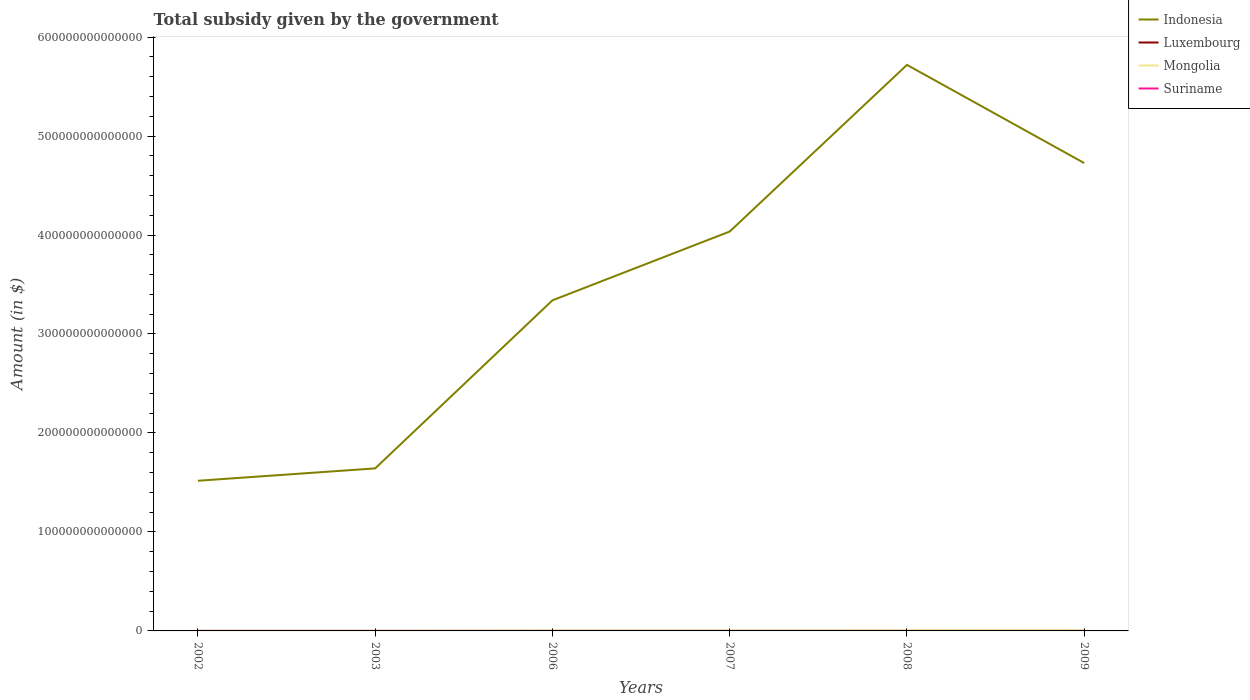How many different coloured lines are there?
Give a very brief answer. 4. Does the line corresponding to Indonesia intersect with the line corresponding to Suriname?
Provide a succinct answer. No. Is the number of lines equal to the number of legend labels?
Your response must be concise. Yes. Across all years, what is the maximum total revenue collected by the government in Indonesia?
Your answer should be very brief. 1.52e+14. What is the total total revenue collected by the government in Indonesia in the graph?
Your response must be concise. -3.21e+14. What is the difference between the highest and the second highest total revenue collected by the government in Luxembourg?
Your response must be concise. 4.64e+09. How many years are there in the graph?
Give a very brief answer. 6. What is the difference between two consecutive major ticks on the Y-axis?
Make the answer very short. 1.00e+14. Are the values on the major ticks of Y-axis written in scientific E-notation?
Provide a short and direct response. No. Where does the legend appear in the graph?
Offer a very short reply. Top right. How many legend labels are there?
Give a very brief answer. 4. How are the legend labels stacked?
Offer a terse response. Vertical. What is the title of the graph?
Provide a succinct answer. Total subsidy given by the government. What is the label or title of the Y-axis?
Provide a succinct answer. Amount (in $). What is the Amount (in $) in Indonesia in 2002?
Provide a short and direct response. 1.52e+14. What is the Amount (in $) in Luxembourg in 2002?
Give a very brief answer. 5.64e+09. What is the Amount (in $) in Mongolia in 2002?
Provide a succinct answer. 1.75e+11. What is the Amount (in $) of Suriname in 2002?
Make the answer very short. 1.62e+08. What is the Amount (in $) of Indonesia in 2003?
Offer a terse response. 1.64e+14. What is the Amount (in $) in Luxembourg in 2003?
Offer a very short reply. 6.17e+09. What is the Amount (in $) of Mongolia in 2003?
Give a very brief answer. 1.38e+11. What is the Amount (in $) in Suriname in 2003?
Your answer should be very brief. 1.98e+08. What is the Amount (in $) in Indonesia in 2006?
Provide a short and direct response. 3.34e+14. What is the Amount (in $) of Luxembourg in 2006?
Offer a very short reply. 8.23e+09. What is the Amount (in $) of Mongolia in 2006?
Make the answer very short. 4.41e+11. What is the Amount (in $) of Suriname in 2006?
Provide a short and direct response. 3.39e+08. What is the Amount (in $) of Indonesia in 2007?
Offer a very short reply. 4.04e+14. What is the Amount (in $) of Luxembourg in 2007?
Offer a very short reply. 8.66e+09. What is the Amount (in $) of Mongolia in 2007?
Your answer should be compact. 4.19e+11. What is the Amount (in $) in Suriname in 2007?
Provide a succinct answer. 3.92e+08. What is the Amount (in $) in Indonesia in 2008?
Your response must be concise. 5.72e+14. What is the Amount (in $) in Luxembourg in 2008?
Ensure brevity in your answer.  9.41e+09. What is the Amount (in $) in Mongolia in 2008?
Provide a short and direct response. 6.67e+11. What is the Amount (in $) in Suriname in 2008?
Ensure brevity in your answer.  4.36e+08. What is the Amount (in $) in Indonesia in 2009?
Make the answer very short. 4.73e+14. What is the Amount (in $) in Luxembourg in 2009?
Offer a terse response. 1.03e+1. What is the Amount (in $) in Mongolia in 2009?
Offer a very short reply. 7.77e+11. What is the Amount (in $) of Suriname in 2009?
Offer a very short reply. 5.00e+08. Across all years, what is the maximum Amount (in $) of Indonesia?
Offer a terse response. 5.72e+14. Across all years, what is the maximum Amount (in $) of Luxembourg?
Offer a terse response. 1.03e+1. Across all years, what is the maximum Amount (in $) of Mongolia?
Your answer should be very brief. 7.77e+11. Across all years, what is the maximum Amount (in $) of Suriname?
Provide a short and direct response. 5.00e+08. Across all years, what is the minimum Amount (in $) of Indonesia?
Your answer should be compact. 1.52e+14. Across all years, what is the minimum Amount (in $) of Luxembourg?
Offer a terse response. 5.64e+09. Across all years, what is the minimum Amount (in $) in Mongolia?
Offer a terse response. 1.38e+11. Across all years, what is the minimum Amount (in $) of Suriname?
Your answer should be very brief. 1.62e+08. What is the total Amount (in $) in Indonesia in the graph?
Provide a short and direct response. 2.10e+15. What is the total Amount (in $) of Luxembourg in the graph?
Offer a very short reply. 4.84e+1. What is the total Amount (in $) of Mongolia in the graph?
Keep it short and to the point. 2.62e+12. What is the total Amount (in $) of Suriname in the graph?
Your response must be concise. 2.03e+09. What is the difference between the Amount (in $) of Indonesia in 2002 and that in 2003?
Provide a succinct answer. -1.25e+13. What is the difference between the Amount (in $) in Luxembourg in 2002 and that in 2003?
Keep it short and to the point. -5.28e+08. What is the difference between the Amount (in $) of Mongolia in 2002 and that in 2003?
Your response must be concise. 3.69e+1. What is the difference between the Amount (in $) of Suriname in 2002 and that in 2003?
Ensure brevity in your answer.  -3.60e+07. What is the difference between the Amount (in $) of Indonesia in 2002 and that in 2006?
Your answer should be compact. -1.82e+14. What is the difference between the Amount (in $) of Luxembourg in 2002 and that in 2006?
Ensure brevity in your answer.  -2.59e+09. What is the difference between the Amount (in $) in Mongolia in 2002 and that in 2006?
Provide a succinct answer. -2.67e+11. What is the difference between the Amount (in $) in Suriname in 2002 and that in 2006?
Make the answer very short. -1.77e+08. What is the difference between the Amount (in $) of Indonesia in 2002 and that in 2007?
Ensure brevity in your answer.  -2.52e+14. What is the difference between the Amount (in $) of Luxembourg in 2002 and that in 2007?
Give a very brief answer. -3.02e+09. What is the difference between the Amount (in $) of Mongolia in 2002 and that in 2007?
Your answer should be very brief. -2.44e+11. What is the difference between the Amount (in $) in Suriname in 2002 and that in 2007?
Offer a terse response. -2.30e+08. What is the difference between the Amount (in $) of Indonesia in 2002 and that in 2008?
Give a very brief answer. -4.20e+14. What is the difference between the Amount (in $) of Luxembourg in 2002 and that in 2008?
Offer a very short reply. -3.77e+09. What is the difference between the Amount (in $) of Mongolia in 2002 and that in 2008?
Provide a short and direct response. -4.92e+11. What is the difference between the Amount (in $) of Suriname in 2002 and that in 2008?
Keep it short and to the point. -2.74e+08. What is the difference between the Amount (in $) in Indonesia in 2002 and that in 2009?
Provide a succinct answer. -3.21e+14. What is the difference between the Amount (in $) of Luxembourg in 2002 and that in 2009?
Offer a very short reply. -4.64e+09. What is the difference between the Amount (in $) of Mongolia in 2002 and that in 2009?
Provide a succinct answer. -6.02e+11. What is the difference between the Amount (in $) of Suriname in 2002 and that in 2009?
Offer a terse response. -3.38e+08. What is the difference between the Amount (in $) in Indonesia in 2003 and that in 2006?
Your answer should be compact. -1.70e+14. What is the difference between the Amount (in $) in Luxembourg in 2003 and that in 2006?
Your response must be concise. -2.06e+09. What is the difference between the Amount (in $) of Mongolia in 2003 and that in 2006?
Offer a terse response. -3.04e+11. What is the difference between the Amount (in $) of Suriname in 2003 and that in 2006?
Your response must be concise. -1.41e+08. What is the difference between the Amount (in $) in Indonesia in 2003 and that in 2007?
Provide a short and direct response. -2.39e+14. What is the difference between the Amount (in $) in Luxembourg in 2003 and that in 2007?
Provide a short and direct response. -2.49e+09. What is the difference between the Amount (in $) of Mongolia in 2003 and that in 2007?
Offer a terse response. -2.81e+11. What is the difference between the Amount (in $) of Suriname in 2003 and that in 2007?
Ensure brevity in your answer.  -1.94e+08. What is the difference between the Amount (in $) in Indonesia in 2003 and that in 2008?
Provide a short and direct response. -4.08e+14. What is the difference between the Amount (in $) in Luxembourg in 2003 and that in 2008?
Make the answer very short. -3.24e+09. What is the difference between the Amount (in $) of Mongolia in 2003 and that in 2008?
Your response must be concise. -5.29e+11. What is the difference between the Amount (in $) of Suriname in 2003 and that in 2008?
Provide a succinct answer. -2.38e+08. What is the difference between the Amount (in $) of Indonesia in 2003 and that in 2009?
Provide a succinct answer. -3.08e+14. What is the difference between the Amount (in $) of Luxembourg in 2003 and that in 2009?
Offer a very short reply. -4.11e+09. What is the difference between the Amount (in $) in Mongolia in 2003 and that in 2009?
Offer a very short reply. -6.39e+11. What is the difference between the Amount (in $) in Suriname in 2003 and that in 2009?
Ensure brevity in your answer.  -3.02e+08. What is the difference between the Amount (in $) of Indonesia in 2006 and that in 2007?
Offer a terse response. -6.95e+13. What is the difference between the Amount (in $) in Luxembourg in 2006 and that in 2007?
Your response must be concise. -4.32e+08. What is the difference between the Amount (in $) in Mongolia in 2006 and that in 2007?
Offer a very short reply. 2.24e+1. What is the difference between the Amount (in $) of Suriname in 2006 and that in 2007?
Provide a short and direct response. -5.32e+07. What is the difference between the Amount (in $) in Indonesia in 2006 and that in 2008?
Your answer should be compact. -2.38e+14. What is the difference between the Amount (in $) of Luxembourg in 2006 and that in 2008?
Keep it short and to the point. -1.18e+09. What is the difference between the Amount (in $) of Mongolia in 2006 and that in 2008?
Give a very brief answer. -2.26e+11. What is the difference between the Amount (in $) in Suriname in 2006 and that in 2008?
Your answer should be very brief. -9.70e+07. What is the difference between the Amount (in $) of Indonesia in 2006 and that in 2009?
Give a very brief answer. -1.39e+14. What is the difference between the Amount (in $) in Luxembourg in 2006 and that in 2009?
Make the answer very short. -2.05e+09. What is the difference between the Amount (in $) in Mongolia in 2006 and that in 2009?
Keep it short and to the point. -3.36e+11. What is the difference between the Amount (in $) in Suriname in 2006 and that in 2009?
Provide a succinct answer. -1.61e+08. What is the difference between the Amount (in $) of Indonesia in 2007 and that in 2008?
Your answer should be very brief. -1.68e+14. What is the difference between the Amount (in $) of Luxembourg in 2007 and that in 2008?
Your answer should be very brief. -7.48e+08. What is the difference between the Amount (in $) of Mongolia in 2007 and that in 2008?
Ensure brevity in your answer.  -2.48e+11. What is the difference between the Amount (in $) in Suriname in 2007 and that in 2008?
Your answer should be compact. -4.38e+07. What is the difference between the Amount (in $) in Indonesia in 2007 and that in 2009?
Make the answer very short. -6.92e+13. What is the difference between the Amount (in $) of Luxembourg in 2007 and that in 2009?
Offer a very short reply. -1.62e+09. What is the difference between the Amount (in $) in Mongolia in 2007 and that in 2009?
Give a very brief answer. -3.58e+11. What is the difference between the Amount (in $) of Suriname in 2007 and that in 2009?
Provide a succinct answer. -1.08e+08. What is the difference between the Amount (in $) of Indonesia in 2008 and that in 2009?
Offer a terse response. 9.92e+13. What is the difference between the Amount (in $) in Luxembourg in 2008 and that in 2009?
Provide a succinct answer. -8.68e+08. What is the difference between the Amount (in $) in Mongolia in 2008 and that in 2009?
Your answer should be very brief. -1.10e+11. What is the difference between the Amount (in $) of Suriname in 2008 and that in 2009?
Your answer should be compact. -6.43e+07. What is the difference between the Amount (in $) in Indonesia in 2002 and the Amount (in $) in Luxembourg in 2003?
Offer a very short reply. 1.52e+14. What is the difference between the Amount (in $) in Indonesia in 2002 and the Amount (in $) in Mongolia in 2003?
Give a very brief answer. 1.52e+14. What is the difference between the Amount (in $) in Indonesia in 2002 and the Amount (in $) in Suriname in 2003?
Provide a short and direct response. 1.52e+14. What is the difference between the Amount (in $) in Luxembourg in 2002 and the Amount (in $) in Mongolia in 2003?
Provide a succinct answer. -1.32e+11. What is the difference between the Amount (in $) of Luxembourg in 2002 and the Amount (in $) of Suriname in 2003?
Provide a short and direct response. 5.45e+09. What is the difference between the Amount (in $) of Mongolia in 2002 and the Amount (in $) of Suriname in 2003?
Your response must be concise. 1.75e+11. What is the difference between the Amount (in $) of Indonesia in 2002 and the Amount (in $) of Luxembourg in 2006?
Offer a terse response. 1.52e+14. What is the difference between the Amount (in $) of Indonesia in 2002 and the Amount (in $) of Mongolia in 2006?
Make the answer very short. 1.51e+14. What is the difference between the Amount (in $) in Indonesia in 2002 and the Amount (in $) in Suriname in 2006?
Offer a terse response. 1.52e+14. What is the difference between the Amount (in $) in Luxembourg in 2002 and the Amount (in $) in Mongolia in 2006?
Make the answer very short. -4.36e+11. What is the difference between the Amount (in $) in Luxembourg in 2002 and the Amount (in $) in Suriname in 2006?
Your answer should be compact. 5.30e+09. What is the difference between the Amount (in $) in Mongolia in 2002 and the Amount (in $) in Suriname in 2006?
Make the answer very short. 1.74e+11. What is the difference between the Amount (in $) of Indonesia in 2002 and the Amount (in $) of Luxembourg in 2007?
Offer a terse response. 1.52e+14. What is the difference between the Amount (in $) in Indonesia in 2002 and the Amount (in $) in Mongolia in 2007?
Your answer should be compact. 1.51e+14. What is the difference between the Amount (in $) of Indonesia in 2002 and the Amount (in $) of Suriname in 2007?
Provide a short and direct response. 1.52e+14. What is the difference between the Amount (in $) of Luxembourg in 2002 and the Amount (in $) of Mongolia in 2007?
Make the answer very short. -4.13e+11. What is the difference between the Amount (in $) in Luxembourg in 2002 and the Amount (in $) in Suriname in 2007?
Make the answer very short. 5.25e+09. What is the difference between the Amount (in $) in Mongolia in 2002 and the Amount (in $) in Suriname in 2007?
Offer a terse response. 1.74e+11. What is the difference between the Amount (in $) of Indonesia in 2002 and the Amount (in $) of Luxembourg in 2008?
Offer a terse response. 1.52e+14. What is the difference between the Amount (in $) in Indonesia in 2002 and the Amount (in $) in Mongolia in 2008?
Your answer should be compact. 1.51e+14. What is the difference between the Amount (in $) in Indonesia in 2002 and the Amount (in $) in Suriname in 2008?
Keep it short and to the point. 1.52e+14. What is the difference between the Amount (in $) in Luxembourg in 2002 and the Amount (in $) in Mongolia in 2008?
Provide a succinct answer. -6.61e+11. What is the difference between the Amount (in $) of Luxembourg in 2002 and the Amount (in $) of Suriname in 2008?
Provide a succinct answer. 5.21e+09. What is the difference between the Amount (in $) in Mongolia in 2002 and the Amount (in $) in Suriname in 2008?
Keep it short and to the point. 1.74e+11. What is the difference between the Amount (in $) of Indonesia in 2002 and the Amount (in $) of Luxembourg in 2009?
Your answer should be compact. 1.52e+14. What is the difference between the Amount (in $) of Indonesia in 2002 and the Amount (in $) of Mongolia in 2009?
Your response must be concise. 1.51e+14. What is the difference between the Amount (in $) in Indonesia in 2002 and the Amount (in $) in Suriname in 2009?
Make the answer very short. 1.52e+14. What is the difference between the Amount (in $) of Luxembourg in 2002 and the Amount (in $) of Mongolia in 2009?
Your answer should be very brief. -7.71e+11. What is the difference between the Amount (in $) of Luxembourg in 2002 and the Amount (in $) of Suriname in 2009?
Ensure brevity in your answer.  5.14e+09. What is the difference between the Amount (in $) of Mongolia in 2002 and the Amount (in $) of Suriname in 2009?
Your response must be concise. 1.74e+11. What is the difference between the Amount (in $) of Indonesia in 2003 and the Amount (in $) of Luxembourg in 2006?
Make the answer very short. 1.64e+14. What is the difference between the Amount (in $) of Indonesia in 2003 and the Amount (in $) of Mongolia in 2006?
Your response must be concise. 1.64e+14. What is the difference between the Amount (in $) in Indonesia in 2003 and the Amount (in $) in Suriname in 2006?
Your answer should be very brief. 1.64e+14. What is the difference between the Amount (in $) of Luxembourg in 2003 and the Amount (in $) of Mongolia in 2006?
Your answer should be compact. -4.35e+11. What is the difference between the Amount (in $) in Luxembourg in 2003 and the Amount (in $) in Suriname in 2006?
Your response must be concise. 5.83e+09. What is the difference between the Amount (in $) of Mongolia in 2003 and the Amount (in $) of Suriname in 2006?
Your answer should be very brief. 1.37e+11. What is the difference between the Amount (in $) in Indonesia in 2003 and the Amount (in $) in Luxembourg in 2007?
Provide a short and direct response. 1.64e+14. What is the difference between the Amount (in $) in Indonesia in 2003 and the Amount (in $) in Mongolia in 2007?
Give a very brief answer. 1.64e+14. What is the difference between the Amount (in $) of Indonesia in 2003 and the Amount (in $) of Suriname in 2007?
Give a very brief answer. 1.64e+14. What is the difference between the Amount (in $) of Luxembourg in 2003 and the Amount (in $) of Mongolia in 2007?
Offer a terse response. -4.13e+11. What is the difference between the Amount (in $) in Luxembourg in 2003 and the Amount (in $) in Suriname in 2007?
Your response must be concise. 5.78e+09. What is the difference between the Amount (in $) of Mongolia in 2003 and the Amount (in $) of Suriname in 2007?
Give a very brief answer. 1.37e+11. What is the difference between the Amount (in $) of Indonesia in 2003 and the Amount (in $) of Luxembourg in 2008?
Ensure brevity in your answer.  1.64e+14. What is the difference between the Amount (in $) of Indonesia in 2003 and the Amount (in $) of Mongolia in 2008?
Make the answer very short. 1.64e+14. What is the difference between the Amount (in $) of Indonesia in 2003 and the Amount (in $) of Suriname in 2008?
Your response must be concise. 1.64e+14. What is the difference between the Amount (in $) in Luxembourg in 2003 and the Amount (in $) in Mongolia in 2008?
Your response must be concise. -6.61e+11. What is the difference between the Amount (in $) in Luxembourg in 2003 and the Amount (in $) in Suriname in 2008?
Make the answer very short. 5.74e+09. What is the difference between the Amount (in $) of Mongolia in 2003 and the Amount (in $) of Suriname in 2008?
Provide a succinct answer. 1.37e+11. What is the difference between the Amount (in $) of Indonesia in 2003 and the Amount (in $) of Luxembourg in 2009?
Your answer should be compact. 1.64e+14. What is the difference between the Amount (in $) in Indonesia in 2003 and the Amount (in $) in Mongolia in 2009?
Provide a succinct answer. 1.63e+14. What is the difference between the Amount (in $) in Indonesia in 2003 and the Amount (in $) in Suriname in 2009?
Your answer should be compact. 1.64e+14. What is the difference between the Amount (in $) in Luxembourg in 2003 and the Amount (in $) in Mongolia in 2009?
Keep it short and to the point. -7.71e+11. What is the difference between the Amount (in $) in Luxembourg in 2003 and the Amount (in $) in Suriname in 2009?
Make the answer very short. 5.67e+09. What is the difference between the Amount (in $) of Mongolia in 2003 and the Amount (in $) of Suriname in 2009?
Your answer should be compact. 1.37e+11. What is the difference between the Amount (in $) in Indonesia in 2006 and the Amount (in $) in Luxembourg in 2007?
Provide a succinct answer. 3.34e+14. What is the difference between the Amount (in $) of Indonesia in 2006 and the Amount (in $) of Mongolia in 2007?
Provide a succinct answer. 3.34e+14. What is the difference between the Amount (in $) of Indonesia in 2006 and the Amount (in $) of Suriname in 2007?
Your answer should be compact. 3.34e+14. What is the difference between the Amount (in $) in Luxembourg in 2006 and the Amount (in $) in Mongolia in 2007?
Provide a short and direct response. -4.11e+11. What is the difference between the Amount (in $) in Luxembourg in 2006 and the Amount (in $) in Suriname in 2007?
Make the answer very short. 7.84e+09. What is the difference between the Amount (in $) of Mongolia in 2006 and the Amount (in $) of Suriname in 2007?
Provide a short and direct response. 4.41e+11. What is the difference between the Amount (in $) of Indonesia in 2006 and the Amount (in $) of Luxembourg in 2008?
Keep it short and to the point. 3.34e+14. What is the difference between the Amount (in $) of Indonesia in 2006 and the Amount (in $) of Mongolia in 2008?
Provide a short and direct response. 3.33e+14. What is the difference between the Amount (in $) in Indonesia in 2006 and the Amount (in $) in Suriname in 2008?
Give a very brief answer. 3.34e+14. What is the difference between the Amount (in $) in Luxembourg in 2006 and the Amount (in $) in Mongolia in 2008?
Give a very brief answer. -6.59e+11. What is the difference between the Amount (in $) of Luxembourg in 2006 and the Amount (in $) of Suriname in 2008?
Provide a succinct answer. 7.80e+09. What is the difference between the Amount (in $) of Mongolia in 2006 and the Amount (in $) of Suriname in 2008?
Provide a short and direct response. 4.41e+11. What is the difference between the Amount (in $) in Indonesia in 2006 and the Amount (in $) in Luxembourg in 2009?
Keep it short and to the point. 3.34e+14. What is the difference between the Amount (in $) of Indonesia in 2006 and the Amount (in $) of Mongolia in 2009?
Provide a succinct answer. 3.33e+14. What is the difference between the Amount (in $) of Indonesia in 2006 and the Amount (in $) of Suriname in 2009?
Ensure brevity in your answer.  3.34e+14. What is the difference between the Amount (in $) of Luxembourg in 2006 and the Amount (in $) of Mongolia in 2009?
Keep it short and to the point. -7.69e+11. What is the difference between the Amount (in $) of Luxembourg in 2006 and the Amount (in $) of Suriname in 2009?
Your answer should be compact. 7.73e+09. What is the difference between the Amount (in $) of Mongolia in 2006 and the Amount (in $) of Suriname in 2009?
Provide a succinct answer. 4.41e+11. What is the difference between the Amount (in $) of Indonesia in 2007 and the Amount (in $) of Luxembourg in 2008?
Provide a succinct answer. 4.04e+14. What is the difference between the Amount (in $) in Indonesia in 2007 and the Amount (in $) in Mongolia in 2008?
Ensure brevity in your answer.  4.03e+14. What is the difference between the Amount (in $) of Indonesia in 2007 and the Amount (in $) of Suriname in 2008?
Keep it short and to the point. 4.04e+14. What is the difference between the Amount (in $) of Luxembourg in 2007 and the Amount (in $) of Mongolia in 2008?
Provide a succinct answer. -6.58e+11. What is the difference between the Amount (in $) of Luxembourg in 2007 and the Amount (in $) of Suriname in 2008?
Your response must be concise. 8.23e+09. What is the difference between the Amount (in $) of Mongolia in 2007 and the Amount (in $) of Suriname in 2008?
Provide a succinct answer. 4.18e+11. What is the difference between the Amount (in $) of Indonesia in 2007 and the Amount (in $) of Luxembourg in 2009?
Ensure brevity in your answer.  4.04e+14. What is the difference between the Amount (in $) of Indonesia in 2007 and the Amount (in $) of Mongolia in 2009?
Make the answer very short. 4.03e+14. What is the difference between the Amount (in $) in Indonesia in 2007 and the Amount (in $) in Suriname in 2009?
Offer a very short reply. 4.04e+14. What is the difference between the Amount (in $) in Luxembourg in 2007 and the Amount (in $) in Mongolia in 2009?
Provide a short and direct response. -7.68e+11. What is the difference between the Amount (in $) of Luxembourg in 2007 and the Amount (in $) of Suriname in 2009?
Ensure brevity in your answer.  8.16e+09. What is the difference between the Amount (in $) of Mongolia in 2007 and the Amount (in $) of Suriname in 2009?
Keep it short and to the point. 4.18e+11. What is the difference between the Amount (in $) in Indonesia in 2008 and the Amount (in $) in Luxembourg in 2009?
Give a very brief answer. 5.72e+14. What is the difference between the Amount (in $) in Indonesia in 2008 and the Amount (in $) in Mongolia in 2009?
Offer a terse response. 5.71e+14. What is the difference between the Amount (in $) of Indonesia in 2008 and the Amount (in $) of Suriname in 2009?
Your answer should be very brief. 5.72e+14. What is the difference between the Amount (in $) in Luxembourg in 2008 and the Amount (in $) in Mongolia in 2009?
Your answer should be very brief. -7.68e+11. What is the difference between the Amount (in $) of Luxembourg in 2008 and the Amount (in $) of Suriname in 2009?
Make the answer very short. 8.91e+09. What is the difference between the Amount (in $) in Mongolia in 2008 and the Amount (in $) in Suriname in 2009?
Provide a succinct answer. 6.66e+11. What is the average Amount (in $) in Indonesia per year?
Provide a succinct answer. 3.50e+14. What is the average Amount (in $) in Luxembourg per year?
Your response must be concise. 8.07e+09. What is the average Amount (in $) in Mongolia per year?
Your answer should be very brief. 4.36e+11. What is the average Amount (in $) in Suriname per year?
Give a very brief answer. 3.38e+08. In the year 2002, what is the difference between the Amount (in $) in Indonesia and Amount (in $) in Luxembourg?
Provide a succinct answer. 1.52e+14. In the year 2002, what is the difference between the Amount (in $) in Indonesia and Amount (in $) in Mongolia?
Your answer should be compact. 1.52e+14. In the year 2002, what is the difference between the Amount (in $) of Indonesia and Amount (in $) of Suriname?
Your response must be concise. 1.52e+14. In the year 2002, what is the difference between the Amount (in $) of Luxembourg and Amount (in $) of Mongolia?
Your answer should be very brief. -1.69e+11. In the year 2002, what is the difference between the Amount (in $) in Luxembourg and Amount (in $) in Suriname?
Provide a short and direct response. 5.48e+09. In the year 2002, what is the difference between the Amount (in $) of Mongolia and Amount (in $) of Suriname?
Make the answer very short. 1.75e+11. In the year 2003, what is the difference between the Amount (in $) of Indonesia and Amount (in $) of Luxembourg?
Your answer should be compact. 1.64e+14. In the year 2003, what is the difference between the Amount (in $) in Indonesia and Amount (in $) in Mongolia?
Keep it short and to the point. 1.64e+14. In the year 2003, what is the difference between the Amount (in $) of Indonesia and Amount (in $) of Suriname?
Make the answer very short. 1.64e+14. In the year 2003, what is the difference between the Amount (in $) in Luxembourg and Amount (in $) in Mongolia?
Provide a short and direct response. -1.32e+11. In the year 2003, what is the difference between the Amount (in $) in Luxembourg and Amount (in $) in Suriname?
Your answer should be very brief. 5.97e+09. In the year 2003, what is the difference between the Amount (in $) in Mongolia and Amount (in $) in Suriname?
Offer a very short reply. 1.38e+11. In the year 2006, what is the difference between the Amount (in $) of Indonesia and Amount (in $) of Luxembourg?
Offer a terse response. 3.34e+14. In the year 2006, what is the difference between the Amount (in $) in Indonesia and Amount (in $) in Mongolia?
Offer a very short reply. 3.34e+14. In the year 2006, what is the difference between the Amount (in $) in Indonesia and Amount (in $) in Suriname?
Offer a very short reply. 3.34e+14. In the year 2006, what is the difference between the Amount (in $) of Luxembourg and Amount (in $) of Mongolia?
Keep it short and to the point. -4.33e+11. In the year 2006, what is the difference between the Amount (in $) of Luxembourg and Amount (in $) of Suriname?
Make the answer very short. 7.89e+09. In the year 2006, what is the difference between the Amount (in $) of Mongolia and Amount (in $) of Suriname?
Your answer should be very brief. 4.41e+11. In the year 2007, what is the difference between the Amount (in $) in Indonesia and Amount (in $) in Luxembourg?
Your response must be concise. 4.04e+14. In the year 2007, what is the difference between the Amount (in $) in Indonesia and Amount (in $) in Mongolia?
Provide a short and direct response. 4.03e+14. In the year 2007, what is the difference between the Amount (in $) in Indonesia and Amount (in $) in Suriname?
Your answer should be compact. 4.04e+14. In the year 2007, what is the difference between the Amount (in $) in Luxembourg and Amount (in $) in Mongolia?
Your answer should be very brief. -4.10e+11. In the year 2007, what is the difference between the Amount (in $) in Luxembourg and Amount (in $) in Suriname?
Your answer should be very brief. 8.27e+09. In the year 2007, what is the difference between the Amount (in $) in Mongolia and Amount (in $) in Suriname?
Your answer should be very brief. 4.19e+11. In the year 2008, what is the difference between the Amount (in $) in Indonesia and Amount (in $) in Luxembourg?
Make the answer very short. 5.72e+14. In the year 2008, what is the difference between the Amount (in $) of Indonesia and Amount (in $) of Mongolia?
Offer a very short reply. 5.71e+14. In the year 2008, what is the difference between the Amount (in $) of Indonesia and Amount (in $) of Suriname?
Your answer should be compact. 5.72e+14. In the year 2008, what is the difference between the Amount (in $) in Luxembourg and Amount (in $) in Mongolia?
Offer a terse response. -6.57e+11. In the year 2008, what is the difference between the Amount (in $) of Luxembourg and Amount (in $) of Suriname?
Keep it short and to the point. 8.98e+09. In the year 2008, what is the difference between the Amount (in $) in Mongolia and Amount (in $) in Suriname?
Provide a succinct answer. 6.66e+11. In the year 2009, what is the difference between the Amount (in $) of Indonesia and Amount (in $) of Luxembourg?
Provide a short and direct response. 4.73e+14. In the year 2009, what is the difference between the Amount (in $) of Indonesia and Amount (in $) of Mongolia?
Make the answer very short. 4.72e+14. In the year 2009, what is the difference between the Amount (in $) of Indonesia and Amount (in $) of Suriname?
Ensure brevity in your answer.  4.73e+14. In the year 2009, what is the difference between the Amount (in $) of Luxembourg and Amount (in $) of Mongolia?
Offer a very short reply. -7.67e+11. In the year 2009, what is the difference between the Amount (in $) in Luxembourg and Amount (in $) in Suriname?
Your answer should be very brief. 9.78e+09. In the year 2009, what is the difference between the Amount (in $) in Mongolia and Amount (in $) in Suriname?
Provide a succinct answer. 7.76e+11. What is the ratio of the Amount (in $) in Indonesia in 2002 to that in 2003?
Offer a terse response. 0.92. What is the ratio of the Amount (in $) of Luxembourg in 2002 to that in 2003?
Your answer should be very brief. 0.91. What is the ratio of the Amount (in $) in Mongolia in 2002 to that in 2003?
Your response must be concise. 1.27. What is the ratio of the Amount (in $) in Suriname in 2002 to that in 2003?
Make the answer very short. 0.82. What is the ratio of the Amount (in $) of Indonesia in 2002 to that in 2006?
Give a very brief answer. 0.45. What is the ratio of the Amount (in $) of Luxembourg in 2002 to that in 2006?
Keep it short and to the point. 0.69. What is the ratio of the Amount (in $) in Mongolia in 2002 to that in 2006?
Give a very brief answer. 0.4. What is the ratio of the Amount (in $) in Suriname in 2002 to that in 2006?
Keep it short and to the point. 0.48. What is the ratio of the Amount (in $) in Indonesia in 2002 to that in 2007?
Offer a terse response. 0.38. What is the ratio of the Amount (in $) of Luxembourg in 2002 to that in 2007?
Provide a short and direct response. 0.65. What is the ratio of the Amount (in $) in Mongolia in 2002 to that in 2007?
Offer a terse response. 0.42. What is the ratio of the Amount (in $) in Suriname in 2002 to that in 2007?
Give a very brief answer. 0.41. What is the ratio of the Amount (in $) in Indonesia in 2002 to that in 2008?
Provide a short and direct response. 0.27. What is the ratio of the Amount (in $) in Luxembourg in 2002 to that in 2008?
Offer a very short reply. 0.6. What is the ratio of the Amount (in $) of Mongolia in 2002 to that in 2008?
Offer a terse response. 0.26. What is the ratio of the Amount (in $) of Suriname in 2002 to that in 2008?
Offer a very short reply. 0.37. What is the ratio of the Amount (in $) of Indonesia in 2002 to that in 2009?
Ensure brevity in your answer.  0.32. What is the ratio of the Amount (in $) of Luxembourg in 2002 to that in 2009?
Your response must be concise. 0.55. What is the ratio of the Amount (in $) of Mongolia in 2002 to that in 2009?
Provide a short and direct response. 0.22. What is the ratio of the Amount (in $) of Suriname in 2002 to that in 2009?
Offer a very short reply. 0.32. What is the ratio of the Amount (in $) of Indonesia in 2003 to that in 2006?
Provide a succinct answer. 0.49. What is the ratio of the Amount (in $) of Luxembourg in 2003 to that in 2006?
Offer a terse response. 0.75. What is the ratio of the Amount (in $) of Mongolia in 2003 to that in 2006?
Ensure brevity in your answer.  0.31. What is the ratio of the Amount (in $) in Suriname in 2003 to that in 2006?
Your answer should be compact. 0.58. What is the ratio of the Amount (in $) of Indonesia in 2003 to that in 2007?
Offer a very short reply. 0.41. What is the ratio of the Amount (in $) of Luxembourg in 2003 to that in 2007?
Provide a succinct answer. 0.71. What is the ratio of the Amount (in $) in Mongolia in 2003 to that in 2007?
Your answer should be compact. 0.33. What is the ratio of the Amount (in $) in Suriname in 2003 to that in 2007?
Offer a terse response. 0.51. What is the ratio of the Amount (in $) of Indonesia in 2003 to that in 2008?
Your answer should be very brief. 0.29. What is the ratio of the Amount (in $) of Luxembourg in 2003 to that in 2008?
Your answer should be compact. 0.66. What is the ratio of the Amount (in $) of Mongolia in 2003 to that in 2008?
Provide a short and direct response. 0.21. What is the ratio of the Amount (in $) in Suriname in 2003 to that in 2008?
Keep it short and to the point. 0.45. What is the ratio of the Amount (in $) in Indonesia in 2003 to that in 2009?
Provide a succinct answer. 0.35. What is the ratio of the Amount (in $) in Luxembourg in 2003 to that in 2009?
Keep it short and to the point. 0.6. What is the ratio of the Amount (in $) of Mongolia in 2003 to that in 2009?
Your response must be concise. 0.18. What is the ratio of the Amount (in $) in Suriname in 2003 to that in 2009?
Offer a terse response. 0.4. What is the ratio of the Amount (in $) in Indonesia in 2006 to that in 2007?
Offer a very short reply. 0.83. What is the ratio of the Amount (in $) in Luxembourg in 2006 to that in 2007?
Make the answer very short. 0.95. What is the ratio of the Amount (in $) of Mongolia in 2006 to that in 2007?
Provide a succinct answer. 1.05. What is the ratio of the Amount (in $) in Suriname in 2006 to that in 2007?
Provide a succinct answer. 0.86. What is the ratio of the Amount (in $) of Indonesia in 2006 to that in 2008?
Your response must be concise. 0.58. What is the ratio of the Amount (in $) in Luxembourg in 2006 to that in 2008?
Offer a terse response. 0.87. What is the ratio of the Amount (in $) of Mongolia in 2006 to that in 2008?
Ensure brevity in your answer.  0.66. What is the ratio of the Amount (in $) in Suriname in 2006 to that in 2008?
Your response must be concise. 0.78. What is the ratio of the Amount (in $) of Indonesia in 2006 to that in 2009?
Provide a short and direct response. 0.71. What is the ratio of the Amount (in $) of Luxembourg in 2006 to that in 2009?
Provide a short and direct response. 0.8. What is the ratio of the Amount (in $) of Mongolia in 2006 to that in 2009?
Provide a short and direct response. 0.57. What is the ratio of the Amount (in $) of Suriname in 2006 to that in 2009?
Give a very brief answer. 0.68. What is the ratio of the Amount (in $) in Indonesia in 2007 to that in 2008?
Your response must be concise. 0.71. What is the ratio of the Amount (in $) in Luxembourg in 2007 to that in 2008?
Provide a succinct answer. 0.92. What is the ratio of the Amount (in $) in Mongolia in 2007 to that in 2008?
Give a very brief answer. 0.63. What is the ratio of the Amount (in $) in Suriname in 2007 to that in 2008?
Keep it short and to the point. 0.9. What is the ratio of the Amount (in $) of Indonesia in 2007 to that in 2009?
Your response must be concise. 0.85. What is the ratio of the Amount (in $) in Luxembourg in 2007 to that in 2009?
Offer a very short reply. 0.84. What is the ratio of the Amount (in $) in Mongolia in 2007 to that in 2009?
Ensure brevity in your answer.  0.54. What is the ratio of the Amount (in $) of Suriname in 2007 to that in 2009?
Your answer should be very brief. 0.78. What is the ratio of the Amount (in $) of Indonesia in 2008 to that in 2009?
Your answer should be compact. 1.21. What is the ratio of the Amount (in $) of Luxembourg in 2008 to that in 2009?
Provide a short and direct response. 0.92. What is the ratio of the Amount (in $) of Mongolia in 2008 to that in 2009?
Give a very brief answer. 0.86. What is the ratio of the Amount (in $) of Suriname in 2008 to that in 2009?
Your response must be concise. 0.87. What is the difference between the highest and the second highest Amount (in $) in Indonesia?
Your answer should be very brief. 9.92e+13. What is the difference between the highest and the second highest Amount (in $) of Luxembourg?
Keep it short and to the point. 8.68e+08. What is the difference between the highest and the second highest Amount (in $) of Mongolia?
Provide a short and direct response. 1.10e+11. What is the difference between the highest and the second highest Amount (in $) of Suriname?
Provide a succinct answer. 6.43e+07. What is the difference between the highest and the lowest Amount (in $) in Indonesia?
Your response must be concise. 4.20e+14. What is the difference between the highest and the lowest Amount (in $) in Luxembourg?
Offer a terse response. 4.64e+09. What is the difference between the highest and the lowest Amount (in $) of Mongolia?
Your answer should be compact. 6.39e+11. What is the difference between the highest and the lowest Amount (in $) of Suriname?
Make the answer very short. 3.38e+08. 